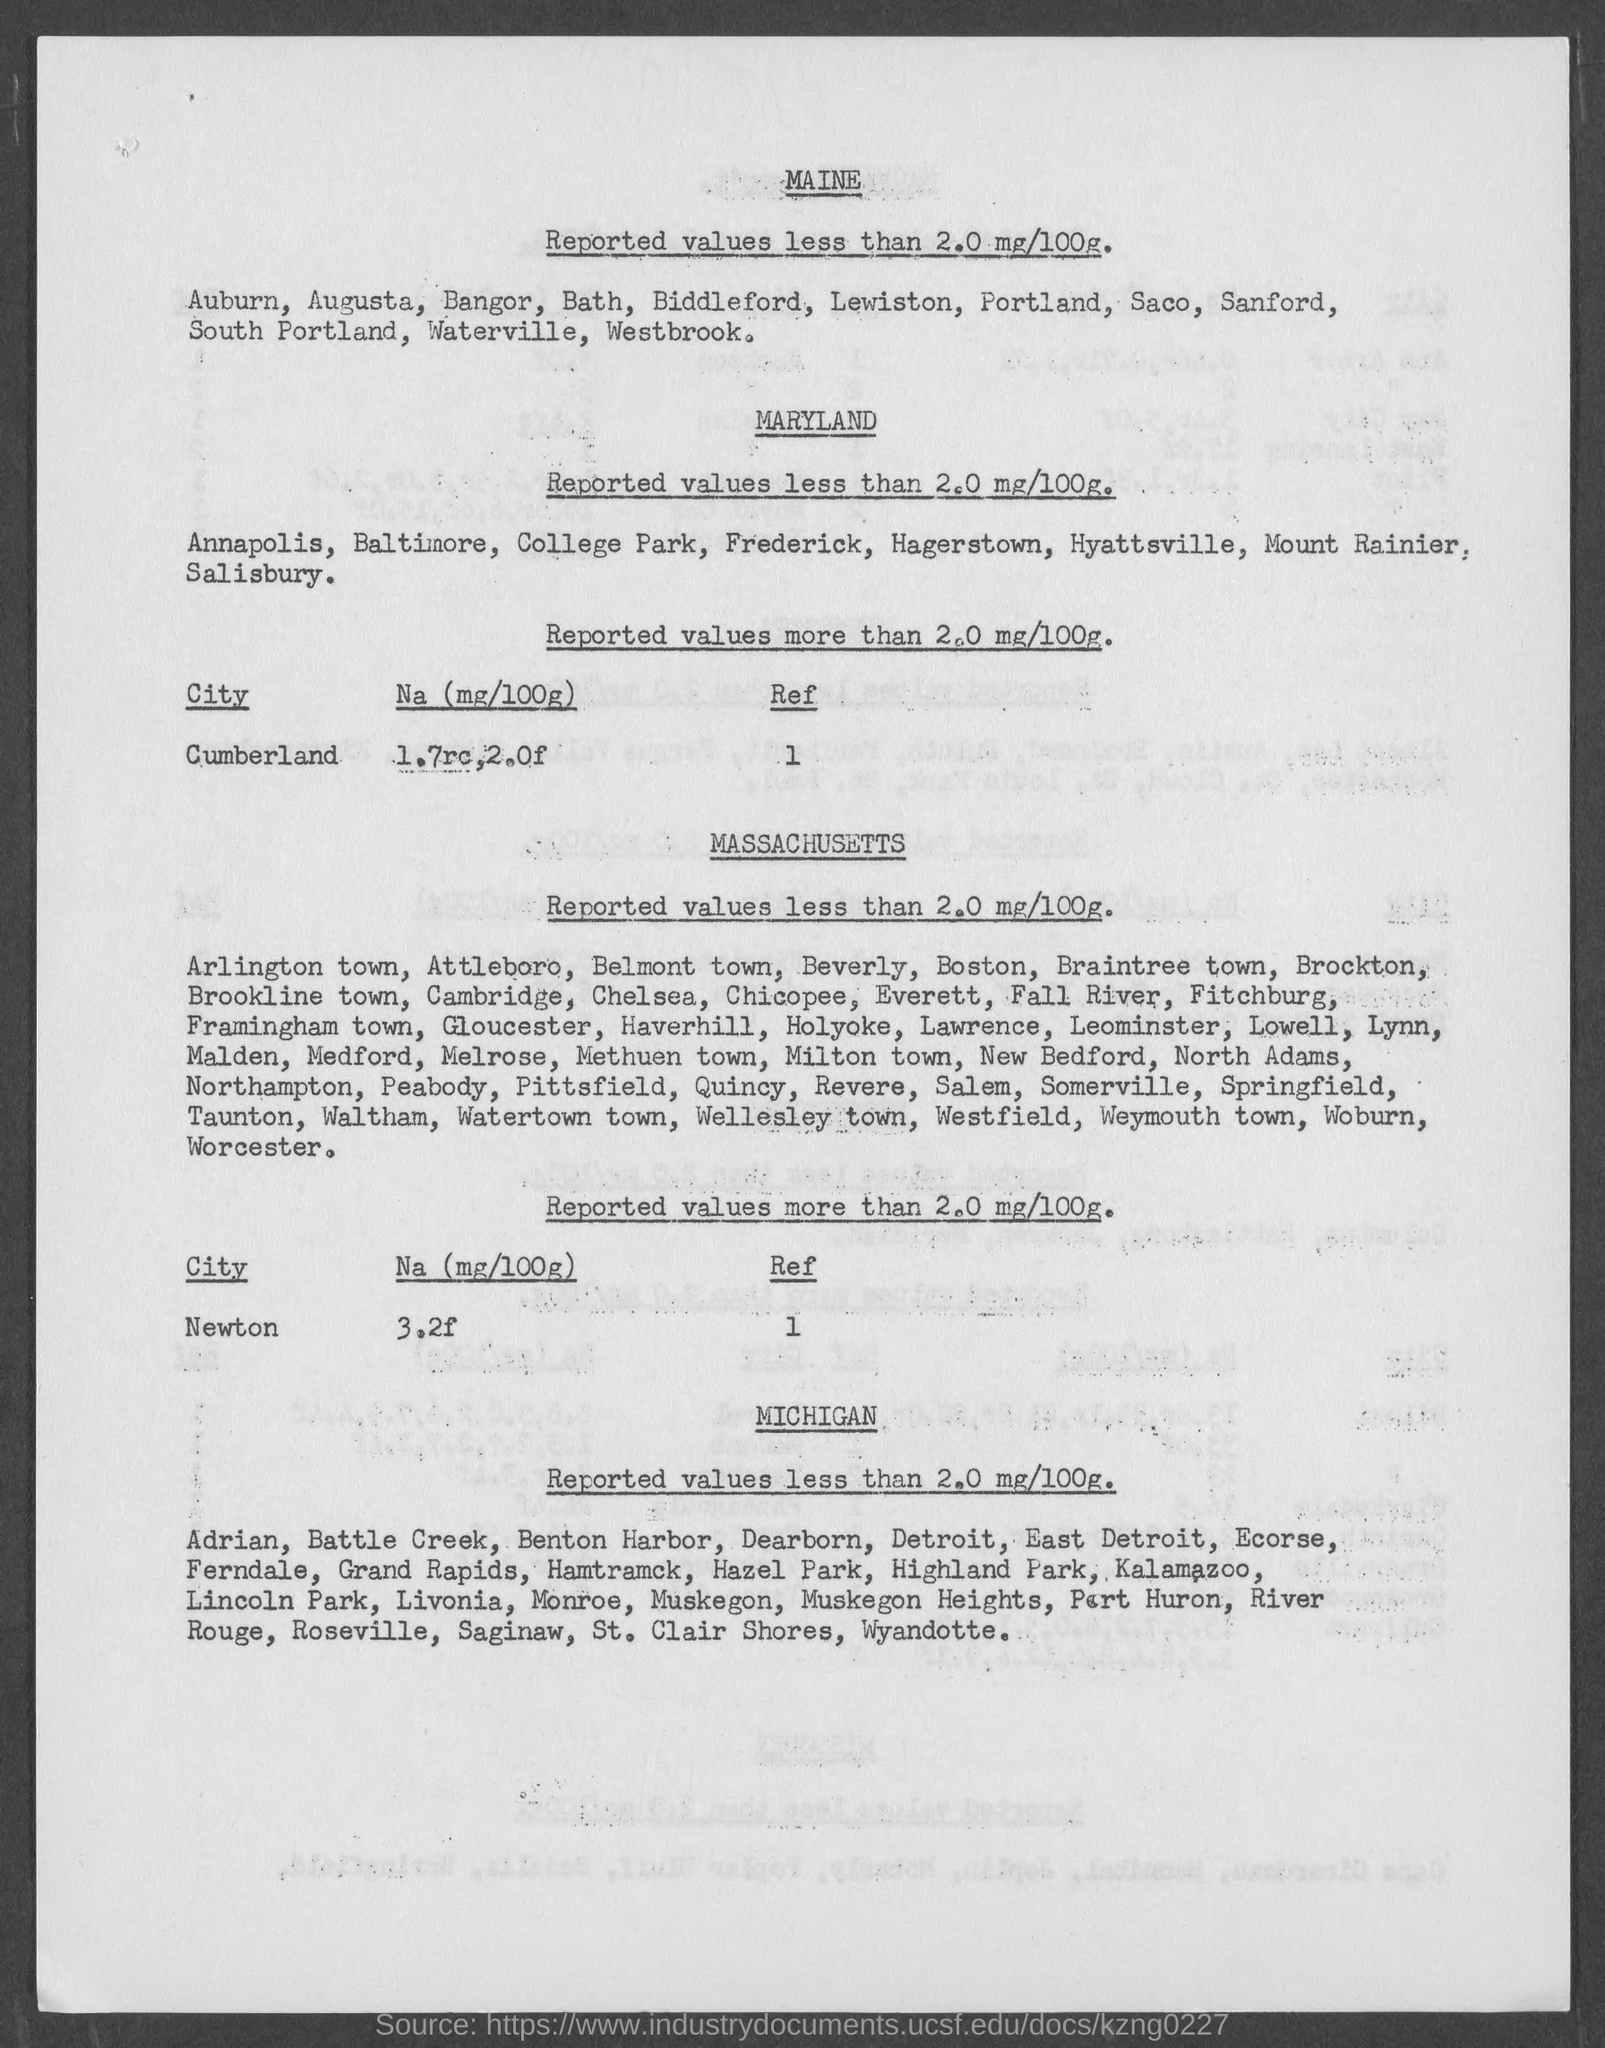What is the na (mg/100g) in newton?
Make the answer very short. 3.2f. 